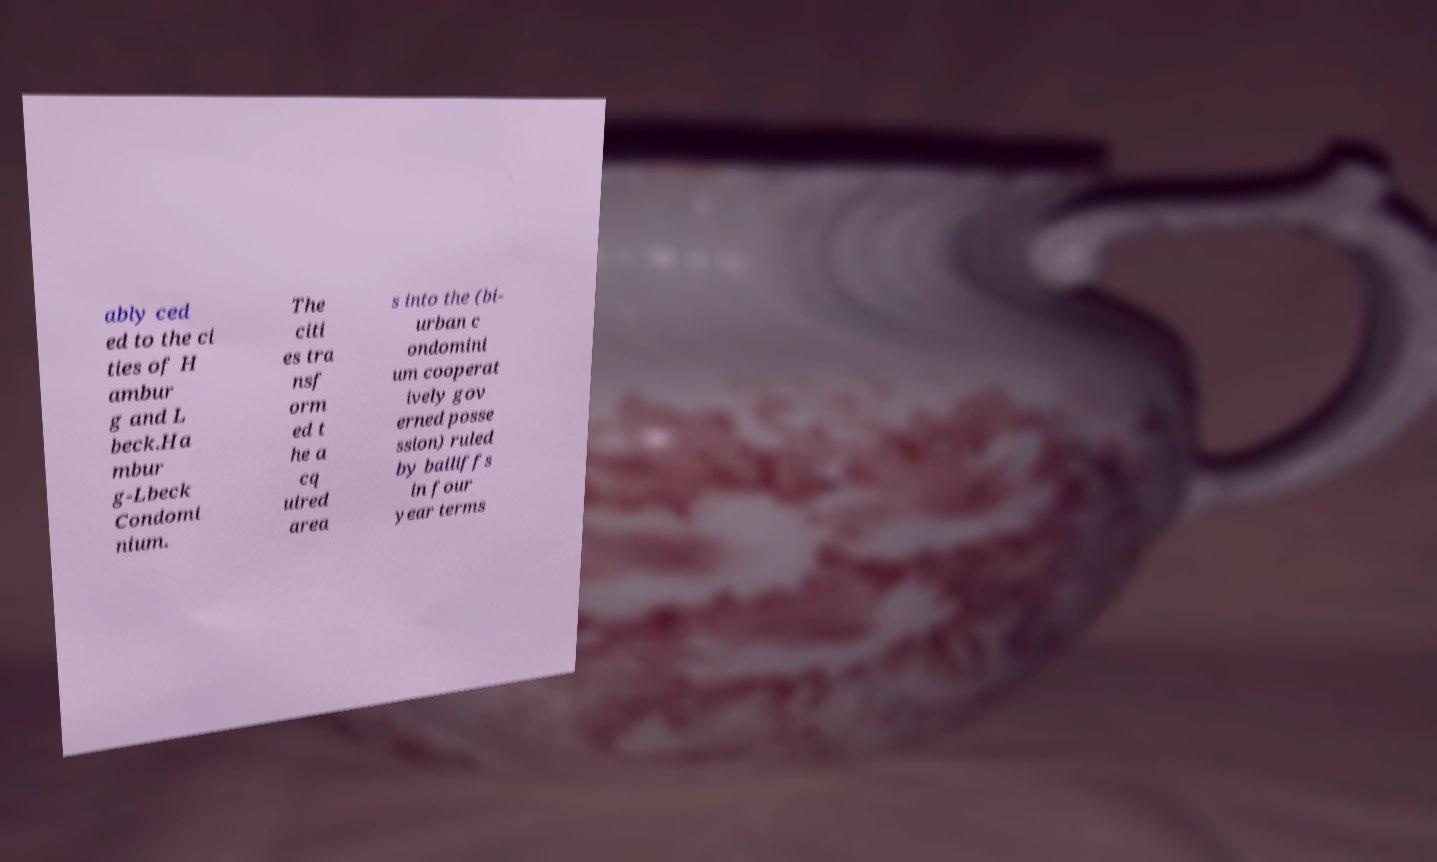What messages or text are displayed in this image? I need them in a readable, typed format. ably ced ed to the ci ties of H ambur g and L beck.Ha mbur g-Lbeck Condomi nium. The citi es tra nsf orm ed t he a cq uired area s into the (bi- urban c ondomini um cooperat ively gov erned posse ssion) ruled by bailiffs in four year terms 